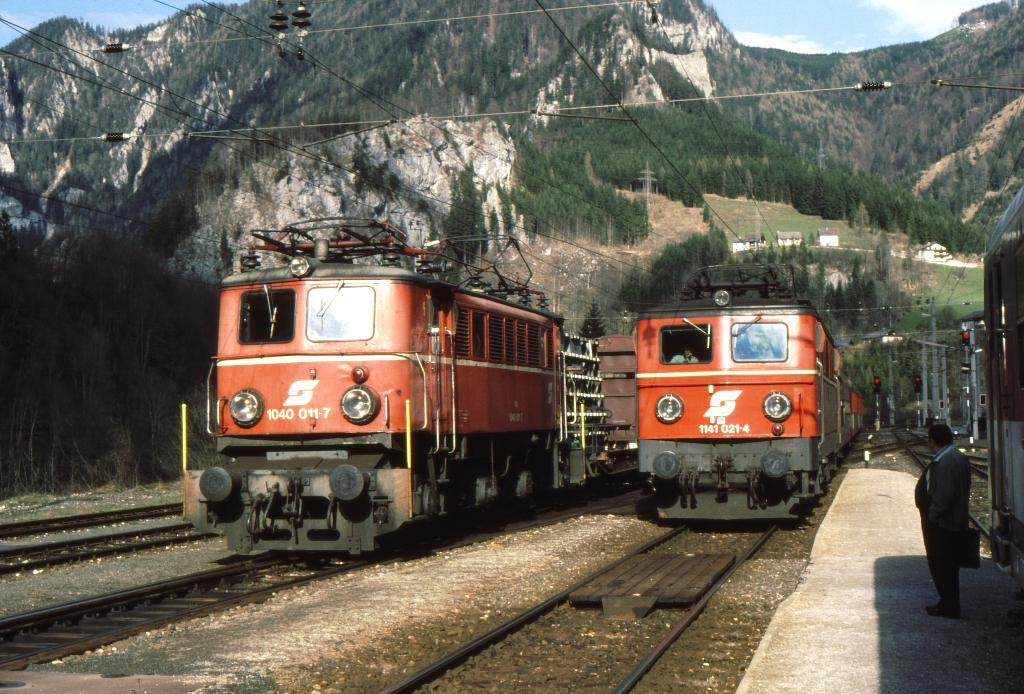<image>
Present a compact description of the photo's key features. Train 1040 011-7 is parked next to another train on the track. 